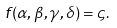Convert formula to latex. <formula><loc_0><loc_0><loc_500><loc_500>f ( \alpha , \beta , \gamma , \delta ) = \varsigma .</formula> 